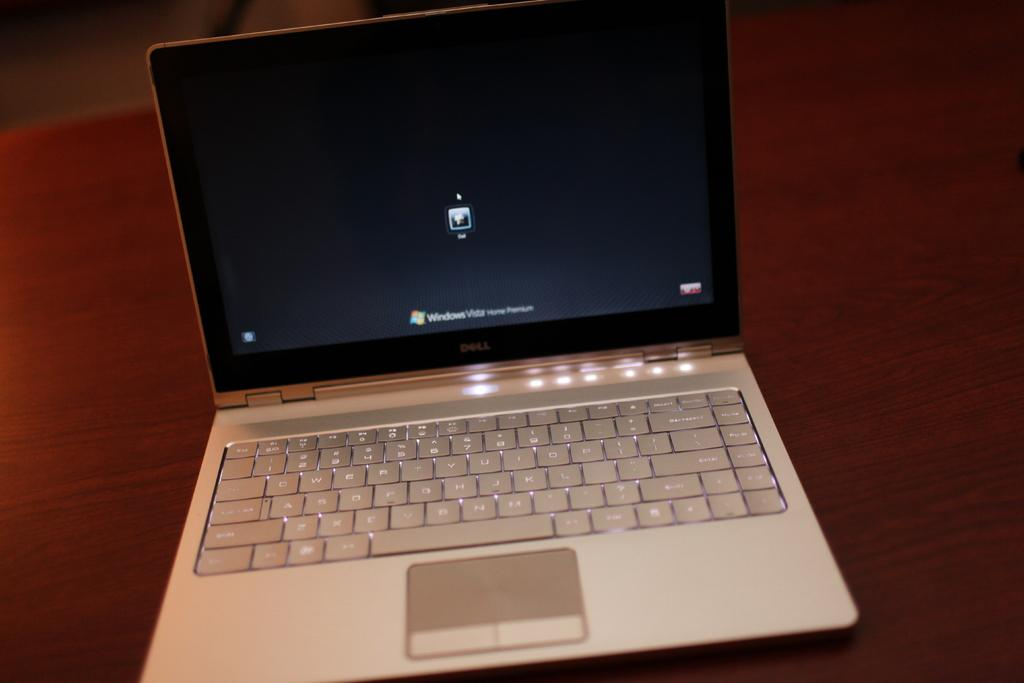<image>
Create a compact narrative representing the image presented. The login screen of a laptop with Windows operating system. 